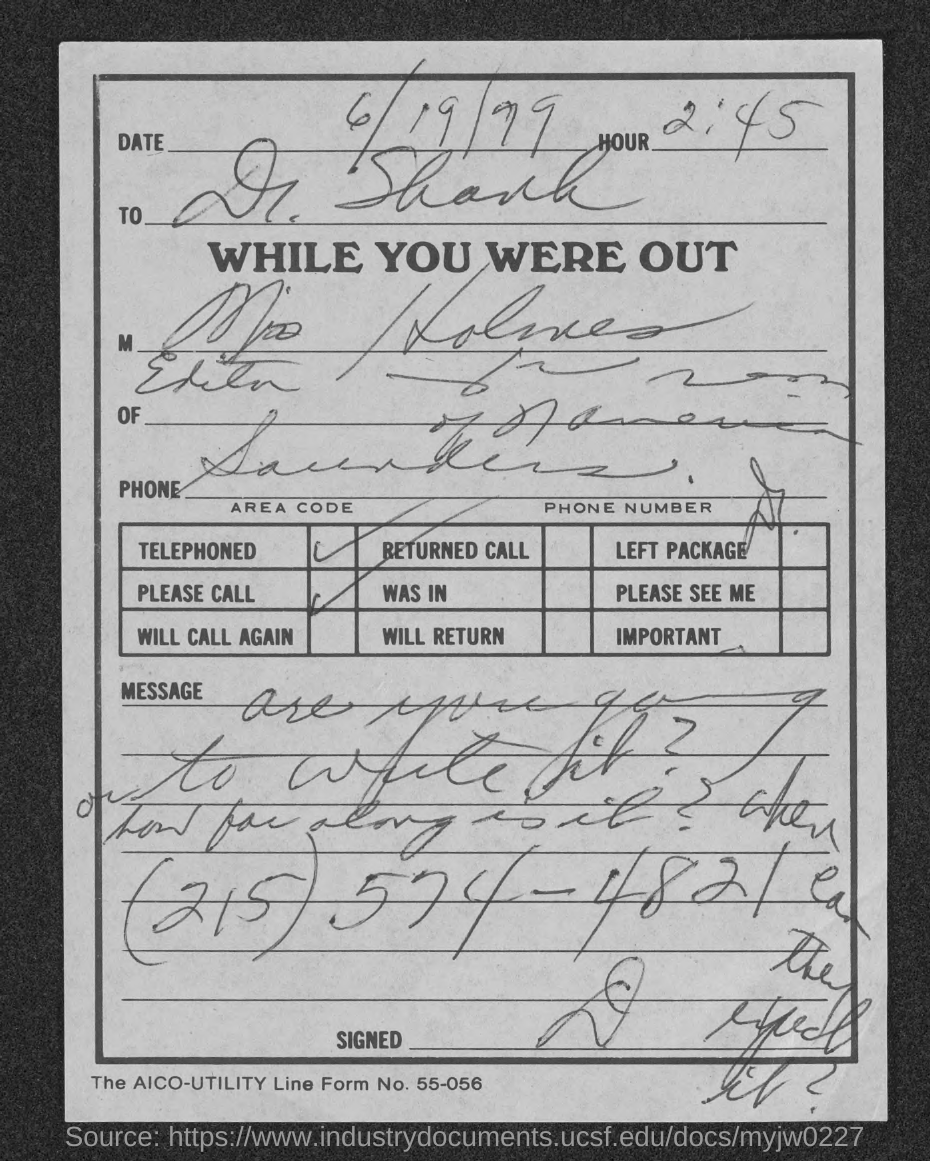Draw attention to some important aspects in this diagram. I need to know the AICO-UTILITY line form number, specifically 55-056... 